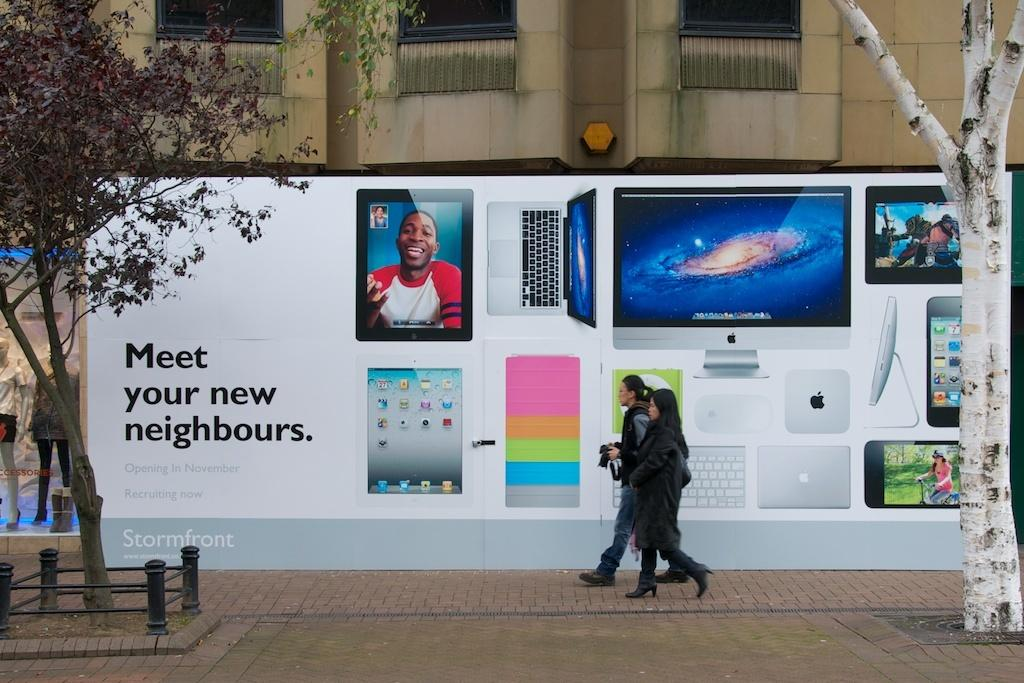<image>
Create a compact narrative representing the image presented. Two people are walking by a large display of electronic images saying meet your new neighbours. 